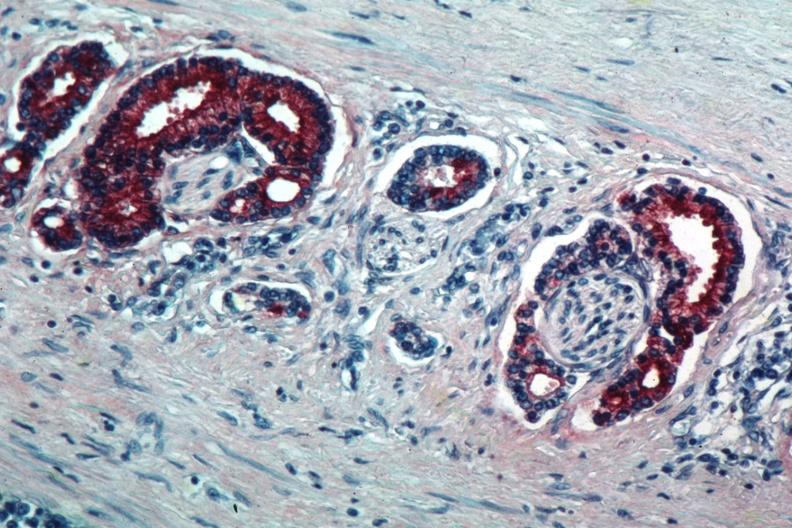what does this image show?
Answer the question using a single word or phrase. Med immunostain for prostate specific antigen shows marked staining in perineural neoplasm 